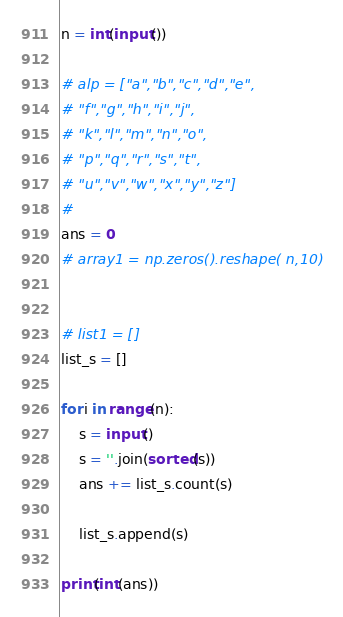<code> <loc_0><loc_0><loc_500><loc_500><_Python_>n = int(input())

# alp = ["a","b","c","d","e",
# "f","g","h","i","j",
# "k","l","m","n","o",
# "p","q","r","s","t",
# "u","v","w","x","y","z"]
#
ans = 0
# array1 = np.zeros().reshape( n,10)


# list1 = []
list_s = []

for i in range(n):
    s = input()
    s = ''.join(sorted(s))
    ans += list_s.count(s)

    list_s.append(s)

print(int(ans))
</code> 